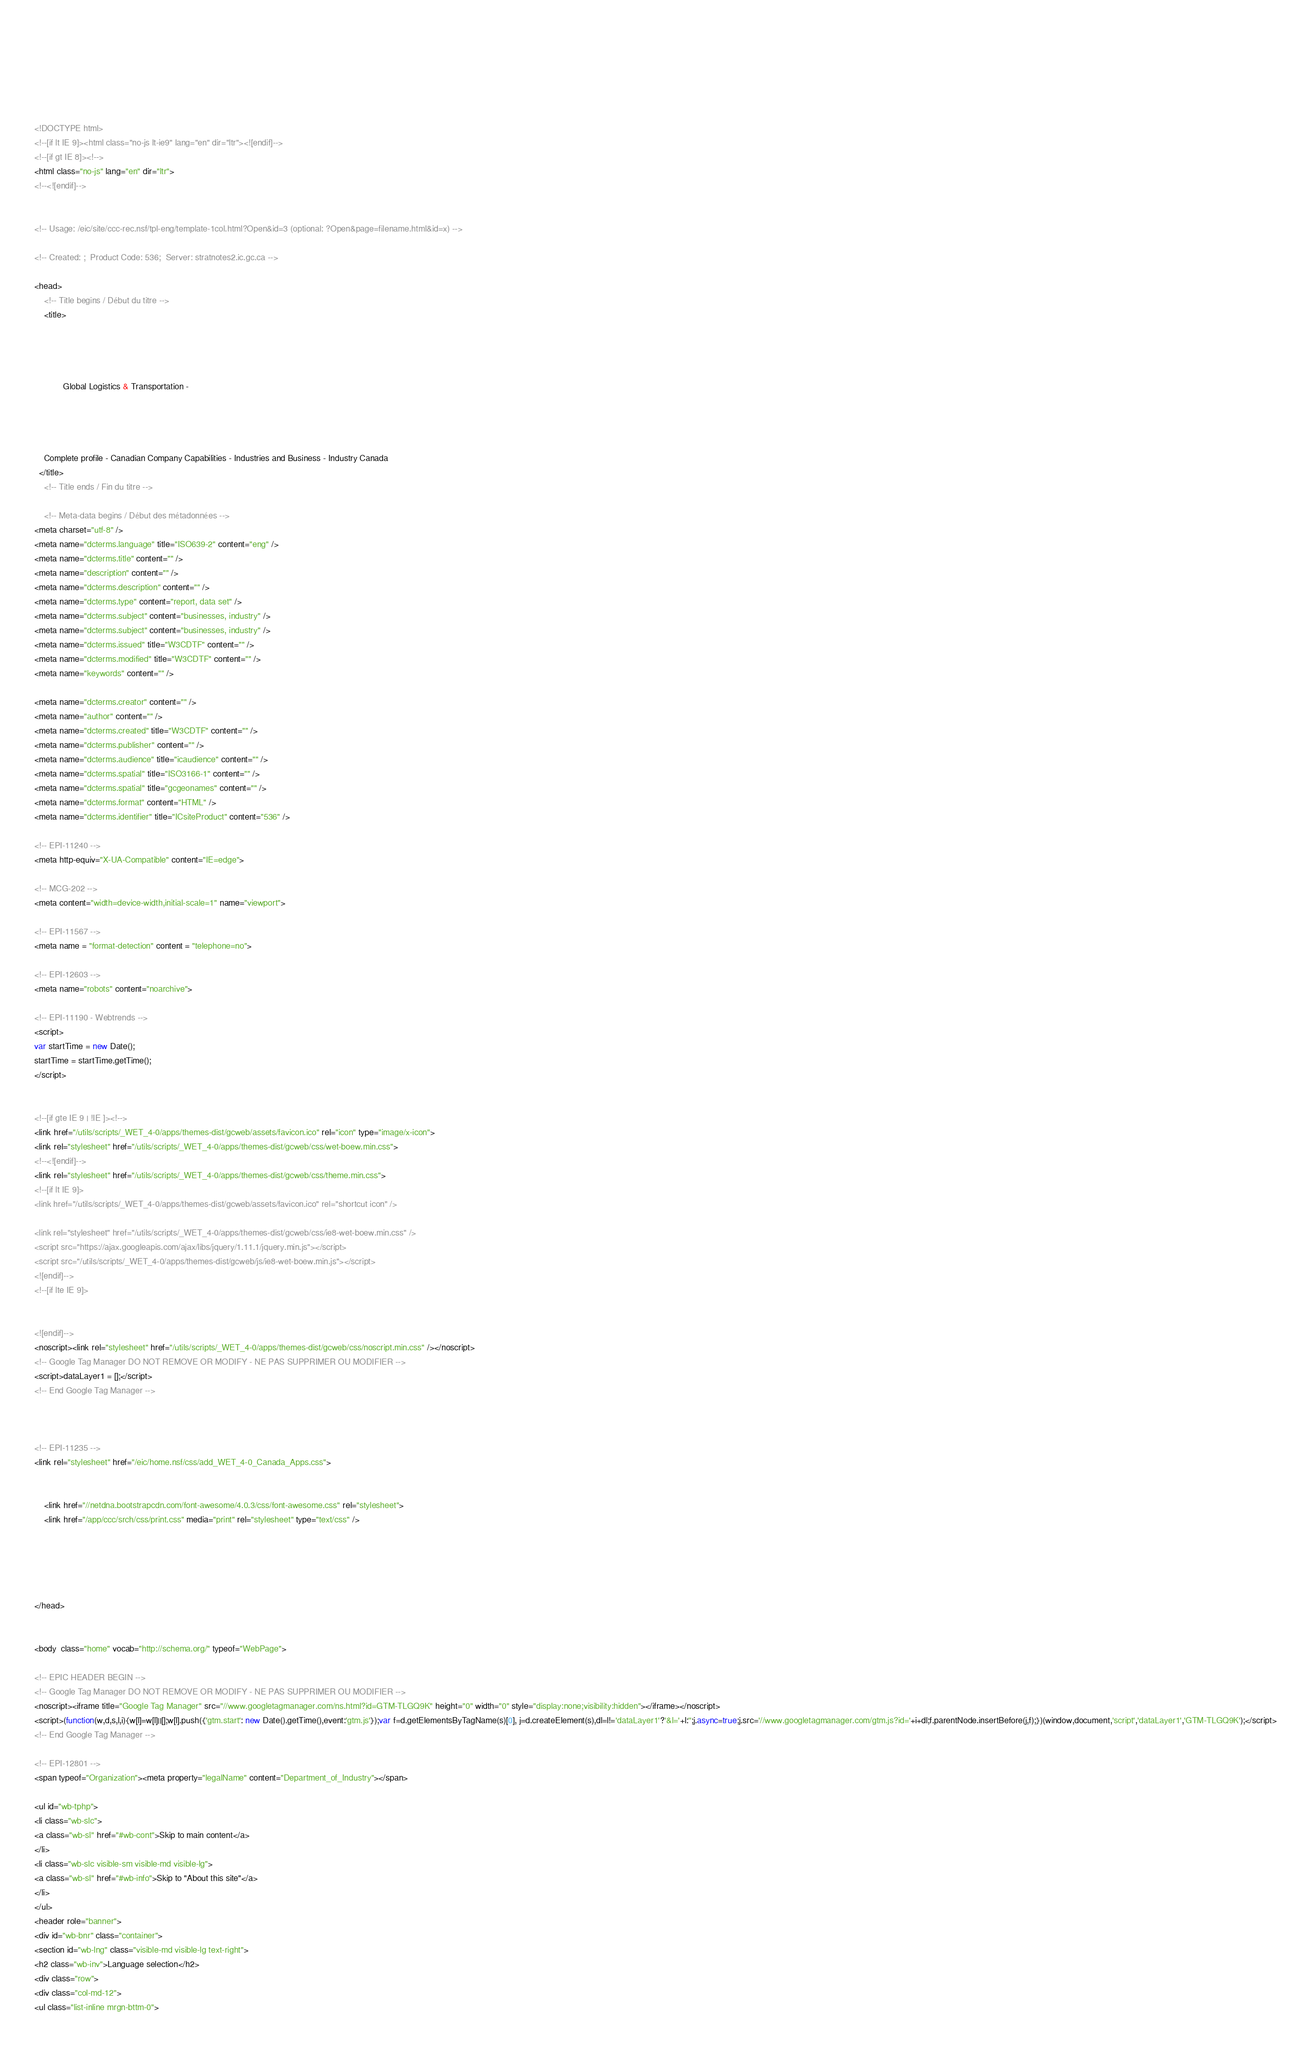Convert code to text. <code><loc_0><loc_0><loc_500><loc_500><_HTML_>













	
	
	



<!DOCTYPE html>
<!--[if lt IE 9]><html class="no-js lt-ie9" lang="en" dir="ltr"><![endif]-->
<!--[if gt IE 8]><!-->
<html class="no-js" lang="en" dir="ltr">
<!--<![endif]-->


<!-- Usage: /eic/site/ccc-rec.nsf/tpl-eng/template-1col.html?Open&id=3 (optional: ?Open&page=filename.html&id=x) -->

<!-- Created: ;  Product Code: 536;  Server: stratnotes2.ic.gc.ca -->

<head>
	<!-- Title begins / Début du titre -->
	<title>
    
            
        
          
            Global Logistics & Transportation -
          
        
      
    
    Complete profile - Canadian Company Capabilities - Industries and Business - Industry Canada
  </title>
	<!-- Title ends / Fin du titre -->
 
	<!-- Meta-data begins / Début des métadonnées -->
<meta charset="utf-8" />
<meta name="dcterms.language" title="ISO639-2" content="eng" />
<meta name="dcterms.title" content="" />
<meta name="description" content="" />
<meta name="dcterms.description" content="" />
<meta name="dcterms.type" content="report, data set" />
<meta name="dcterms.subject" content="businesses, industry" />
<meta name="dcterms.subject" content="businesses, industry" />
<meta name="dcterms.issued" title="W3CDTF" content="" />
<meta name="dcterms.modified" title="W3CDTF" content="" />
<meta name="keywords" content="" />

<meta name="dcterms.creator" content="" />
<meta name="author" content="" />
<meta name="dcterms.created" title="W3CDTF" content="" />
<meta name="dcterms.publisher" content="" />
<meta name="dcterms.audience" title="icaudience" content="" />
<meta name="dcterms.spatial" title="ISO3166-1" content="" />
<meta name="dcterms.spatial" title="gcgeonames" content="" />
<meta name="dcterms.format" content="HTML" />
<meta name="dcterms.identifier" title="ICsiteProduct" content="536" />

<!-- EPI-11240 -->
<meta http-equiv="X-UA-Compatible" content="IE=edge">

<!-- MCG-202 -->
<meta content="width=device-width,initial-scale=1" name="viewport">

<!-- EPI-11567 -->
<meta name = "format-detection" content = "telephone=no">

<!-- EPI-12603 -->
<meta name="robots" content="noarchive">

<!-- EPI-11190 - Webtrends -->
<script>
var startTime = new Date();
startTime = startTime.getTime();
</script>


<!--[if gte IE 9 | !IE ]><!-->
<link href="/utils/scripts/_WET_4-0/apps/themes-dist/gcweb/assets/favicon.ico" rel="icon" type="image/x-icon">
<link rel="stylesheet" href="/utils/scripts/_WET_4-0/apps/themes-dist/gcweb/css/wet-boew.min.css">
<!--<![endif]-->
<link rel="stylesheet" href="/utils/scripts/_WET_4-0/apps/themes-dist/gcweb/css/theme.min.css">
<!--[if lt IE 9]>
<link href="/utils/scripts/_WET_4-0/apps/themes-dist/gcweb/assets/favicon.ico" rel="shortcut icon" />

<link rel="stylesheet" href="/utils/scripts/_WET_4-0/apps/themes-dist/gcweb/css/ie8-wet-boew.min.css" />
<script src="https://ajax.googleapis.com/ajax/libs/jquery/1.11.1/jquery.min.js"></script>
<script src="/utils/scripts/_WET_4-0/apps/themes-dist/gcweb/js/ie8-wet-boew.min.js"></script>
<![endif]-->
<!--[if lte IE 9]>


<![endif]-->
<noscript><link rel="stylesheet" href="/utils/scripts/_WET_4-0/apps/themes-dist/gcweb/css/noscript.min.css" /></noscript>
<!-- Google Tag Manager DO NOT REMOVE OR MODIFY - NE PAS SUPPRIMER OU MODIFIER -->
<script>dataLayer1 = [];</script>
<!-- End Google Tag Manager -->



<!-- EPI-11235 -->
<link rel="stylesheet" href="/eic/home.nsf/css/add_WET_4-0_Canada_Apps.css">


  	<link href="//netdna.bootstrapcdn.com/font-awesome/4.0.3/css/font-awesome.css" rel="stylesheet">
  	<link href="/app/ccc/srch/css/print.css" media="print" rel="stylesheet" type="text/css" />
   




</head>
 

<body  class="home" vocab="http://schema.org/" typeof="WebPage">
 
<!-- EPIC HEADER BEGIN -->
<!-- Google Tag Manager DO NOT REMOVE OR MODIFY - NE PAS SUPPRIMER OU MODIFIER -->
<noscript><iframe title="Google Tag Manager" src="//www.googletagmanager.com/ns.html?id=GTM-TLGQ9K" height="0" width="0" style="display:none;visibility:hidden"></iframe></noscript>
<script>(function(w,d,s,l,i){w[l]=w[l]||[];w[l].push({'gtm.start': new Date().getTime(),event:'gtm.js'});var f=d.getElementsByTagName(s)[0], j=d.createElement(s),dl=l!='dataLayer1'?'&l='+l:'';j.async=true;j.src='//www.googletagmanager.com/gtm.js?id='+i+dl;f.parentNode.insertBefore(j,f);})(window,document,'script','dataLayer1','GTM-TLGQ9K');</script>
<!-- End Google Tag Manager -->

<!-- EPI-12801 -->
<span typeof="Organization"><meta property="legalName" content="Department_of_Industry"></span>

<ul id="wb-tphp">
<li class="wb-slc">
<a class="wb-sl" href="#wb-cont">Skip to main content</a>
</li>
<li class="wb-slc visible-sm visible-md visible-lg">
<a class="wb-sl" href="#wb-info">Skip to "About this site"</a>
</li>
</ul>
<header role="banner">
<div id="wb-bnr" class="container">
<section id="wb-lng" class="visible-md visible-lg text-right">
<h2 class="wb-inv">Language selection</h2>
<div class="row">
<div class="col-md-12">
<ul class="list-inline mrgn-bttm-0"></code> 